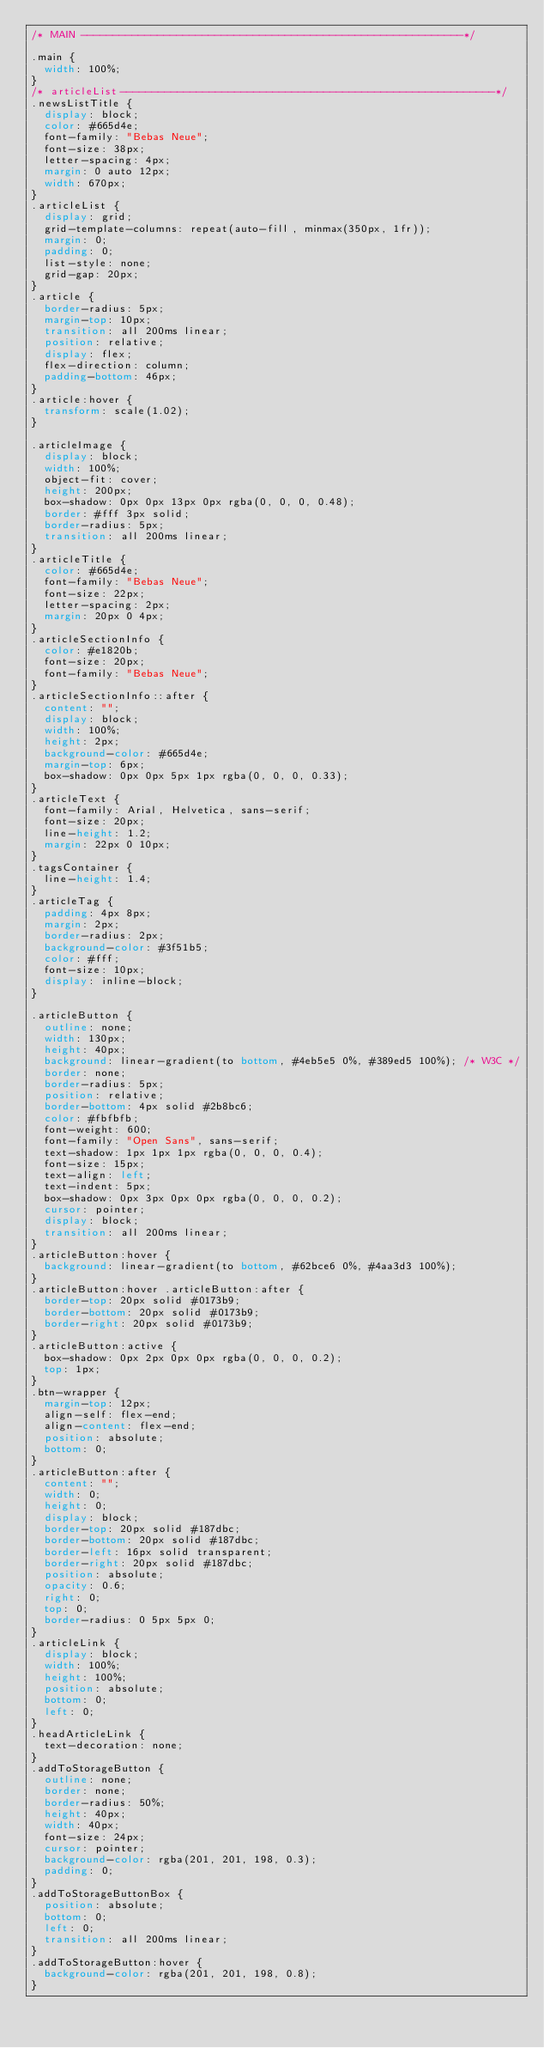<code> <loc_0><loc_0><loc_500><loc_500><_CSS_>/* MAIN ------------------------------------------------------------*/

.main {
  width: 100%;
}
/* articleList-----------------------------------------------------------*/
.newsListTitle {
  display: block;
  color: #665d4e;
  font-family: "Bebas Neue";
  font-size: 38px;
  letter-spacing: 4px;
  margin: 0 auto 12px;
  width: 670px;
}
.articleList {
  display: grid;
  grid-template-columns: repeat(auto-fill, minmax(350px, 1fr));
  margin: 0;
  padding: 0;
  list-style: none;
  grid-gap: 20px;
}
.article {
  border-radius: 5px;
  margin-top: 10px;
  transition: all 200ms linear;
  position: relative;
  display: flex;
  flex-direction: column;
  padding-bottom: 46px;
}
.article:hover {
  transform: scale(1.02);
}

.articleImage {
  display: block;
  width: 100%;
  object-fit: cover;
  height: 200px;
  box-shadow: 0px 0px 13px 0px rgba(0, 0, 0, 0.48);
  border: #fff 3px solid;
  border-radius: 5px;
  transition: all 200ms linear;
}
.articleTitle {
  color: #665d4e;
  font-family: "Bebas Neue";
  font-size: 22px;
  letter-spacing: 2px;
  margin: 20px 0 4px;
}
.articleSectionInfo {
  color: #e1820b;
  font-size: 20px;
  font-family: "Bebas Neue";
}
.articleSectionInfo::after {
  content: "";
  display: block;
  width: 100%;
  height: 2px;
  background-color: #665d4e;
  margin-top: 6px;
  box-shadow: 0px 0px 5px 1px rgba(0, 0, 0, 0.33);
}
.articleText {
  font-family: Arial, Helvetica, sans-serif;
  font-size: 20px;
  line-height: 1.2;
  margin: 22px 0 10px;
}
.tagsContainer {
  line-height: 1.4;
}
.articleTag {
  padding: 4px 8px;
  margin: 2px;
  border-radius: 2px;
  background-color: #3f51b5;
  color: #fff;
  font-size: 10px;
  display: inline-block;
}

.articleButton {
  outline: none;
  width: 130px;
  height: 40px;
  background: linear-gradient(to bottom, #4eb5e5 0%, #389ed5 100%); /* W3C */
  border: none;
  border-radius: 5px;
  position: relative;
  border-bottom: 4px solid #2b8bc6;
  color: #fbfbfb;
  font-weight: 600;
  font-family: "Open Sans", sans-serif;
  text-shadow: 1px 1px 1px rgba(0, 0, 0, 0.4);
  font-size: 15px;
  text-align: left;
  text-indent: 5px;
  box-shadow: 0px 3px 0px 0px rgba(0, 0, 0, 0.2);
  cursor: pointer;
  display: block;
  transition: all 200ms linear;
}
.articleButton:hover {
  background: linear-gradient(to bottom, #62bce6 0%, #4aa3d3 100%);
}
.articleButton:hover .articleButton:after {
  border-top: 20px solid #0173b9;
  border-bottom: 20px solid #0173b9;
  border-right: 20px solid #0173b9;
}
.articleButton:active {
  box-shadow: 0px 2px 0px 0px rgba(0, 0, 0, 0.2);
  top: 1px;
}
.btn-wrapper {
  margin-top: 12px;
  align-self: flex-end;
  align-content: flex-end;
  position: absolute;
  bottom: 0;
}
.articleButton:after {
  content: "";
  width: 0;
  height: 0;
  display: block;
  border-top: 20px solid #187dbc;
  border-bottom: 20px solid #187dbc;
  border-left: 16px solid transparent;
  border-right: 20px solid #187dbc;
  position: absolute;
  opacity: 0.6;
  right: 0;
  top: 0;
  border-radius: 0 5px 5px 0;
}
.articleLink {
  display: block;
  width: 100%;
  height: 100%;
  position: absolute;
  bottom: 0;
  left: 0;
}
.headArticleLink {
  text-decoration: none;
}
.addToStorageButton {
  outline: none;
  border: none;
  border-radius: 50%;
  height: 40px;
  width: 40px;
  font-size: 24px;
  cursor: pointer;
  background-color: rgba(201, 201, 198, 0.3);
  padding: 0;
}
.addToStorageButtonBox {
  position: absolute;
  bottom: 0;
  left: 0;
  transition: all 200ms linear;
}
.addToStorageButton:hover {
  background-color: rgba(201, 201, 198, 0.8);
}
</code> 